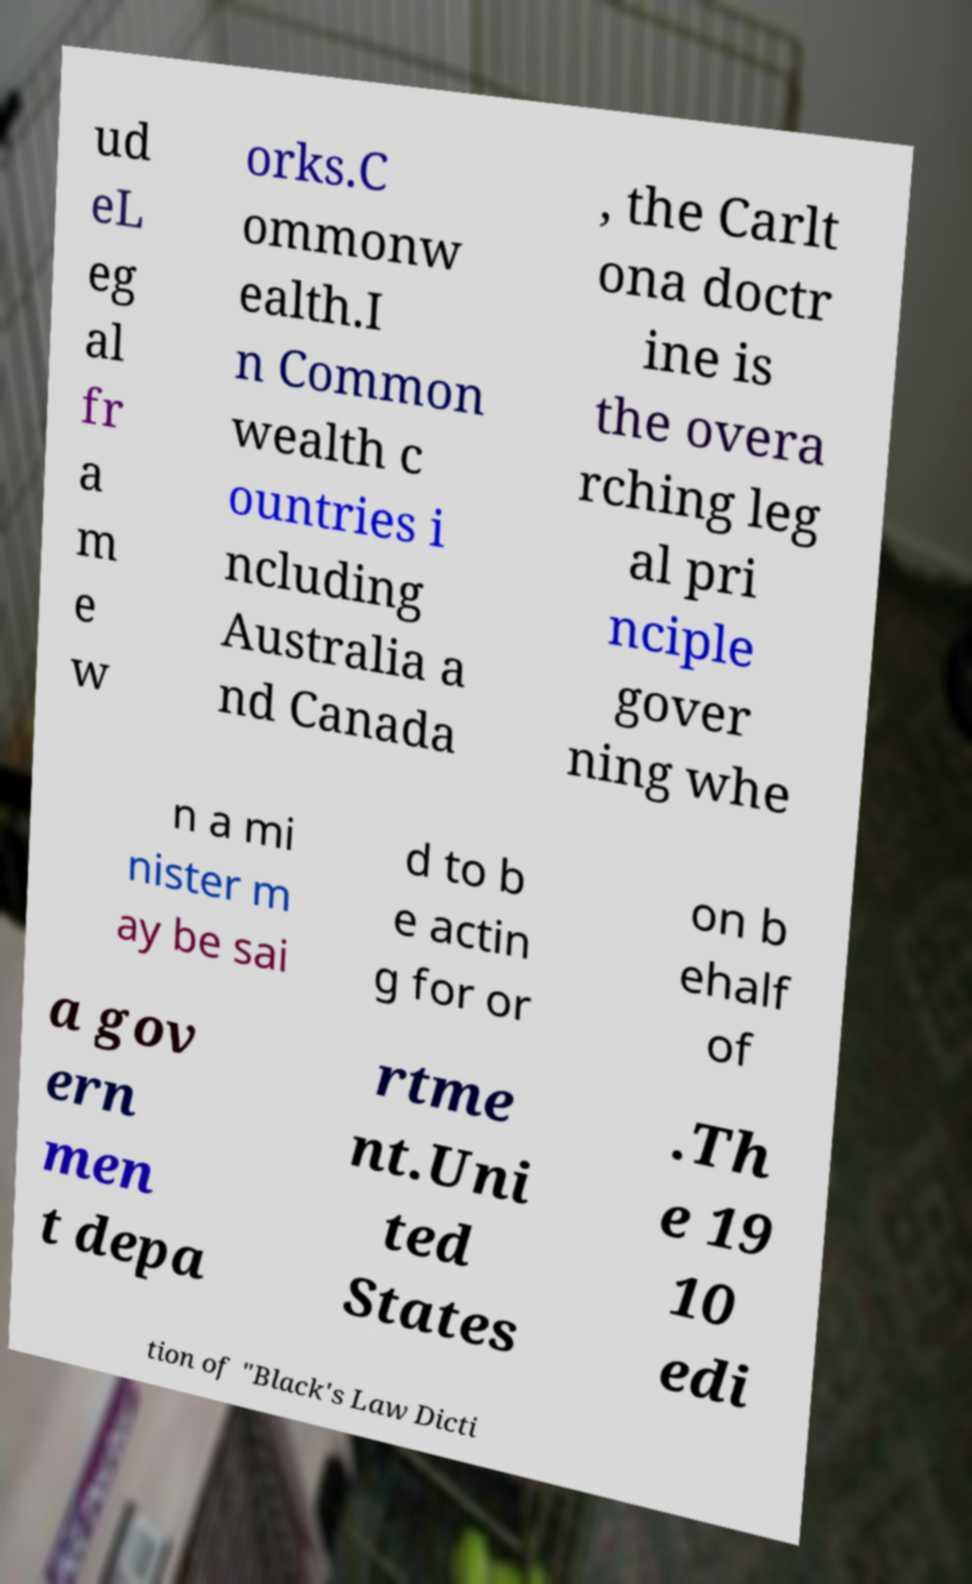For documentation purposes, I need the text within this image transcribed. Could you provide that? ud eL eg al fr a m e w orks.C ommonw ealth.I n Common wealth c ountries i ncluding Australia a nd Canada , the Carlt ona doctr ine is the overa rching leg al pri nciple gover ning whe n a mi nister m ay be sai d to b e actin g for or on b ehalf of a gov ern men t depa rtme nt.Uni ted States .Th e 19 10 edi tion of "Black's Law Dicti 